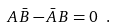<formula> <loc_0><loc_0><loc_500><loc_500>A \, \bar { B } - \bar { A } \, B = 0 \ .</formula> 